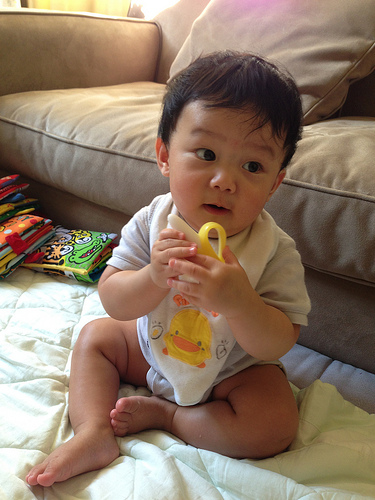<image>
Is the baby on the couch? No. The baby is not positioned on the couch. They may be near each other, but the baby is not supported by or resting on top of the couch. 